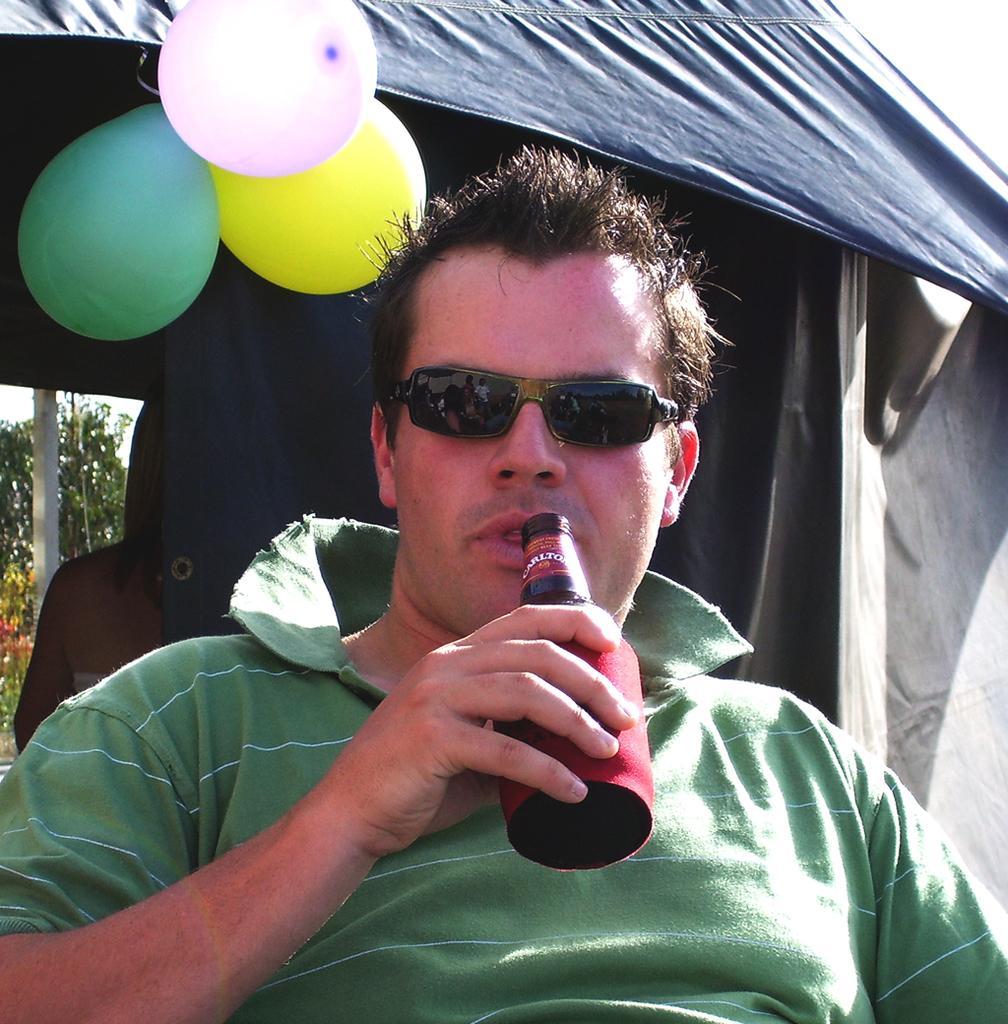Describe this image in one or two sentences. In the middle of the image a man is sitting and holding a bottle. Behind him there is a tent, on the text there are some balloons. Behind the tent a person is standing. Behind her there is a pole and trees. 